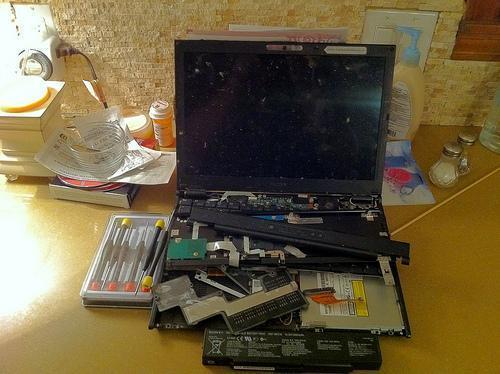How many laptops are pictured?
Give a very brief answer. 1. How many shakers are there?
Give a very brief answer. 2. 